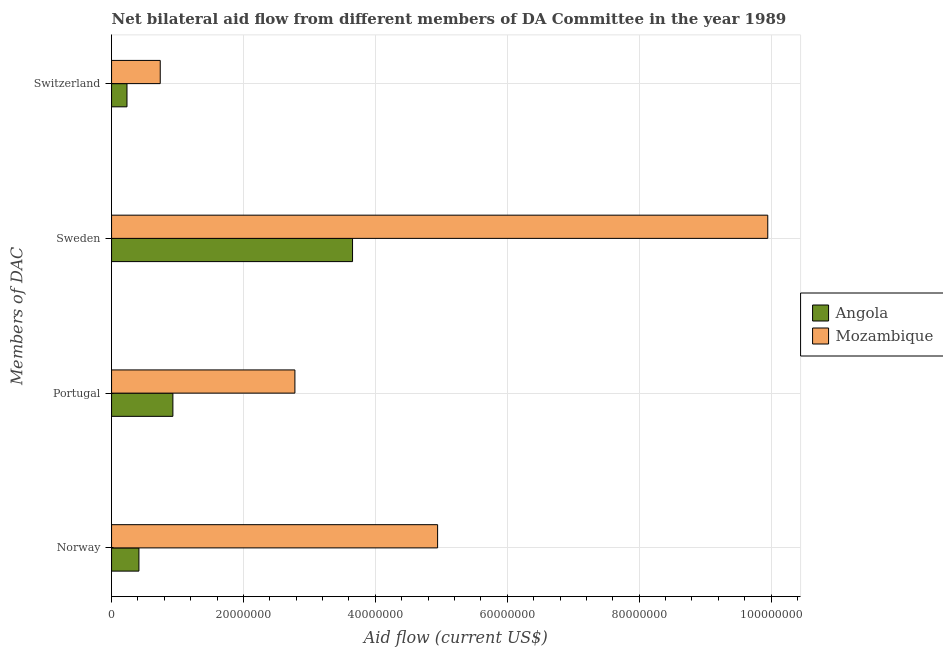How many different coloured bars are there?
Your answer should be compact. 2. How many groups of bars are there?
Make the answer very short. 4. Are the number of bars on each tick of the Y-axis equal?
Provide a succinct answer. Yes. How many bars are there on the 4th tick from the bottom?
Ensure brevity in your answer.  2. What is the label of the 2nd group of bars from the top?
Your answer should be very brief. Sweden. What is the amount of aid given by sweden in Mozambique?
Your answer should be compact. 9.95e+07. Across all countries, what is the maximum amount of aid given by norway?
Your answer should be compact. 4.94e+07. Across all countries, what is the minimum amount of aid given by norway?
Offer a terse response. 4.15e+06. In which country was the amount of aid given by switzerland maximum?
Your answer should be very brief. Mozambique. In which country was the amount of aid given by switzerland minimum?
Provide a succinct answer. Angola. What is the total amount of aid given by sweden in the graph?
Keep it short and to the point. 1.36e+08. What is the difference between the amount of aid given by portugal in Angola and that in Mozambique?
Keep it short and to the point. -1.85e+07. What is the difference between the amount of aid given by norway in Mozambique and the amount of aid given by switzerland in Angola?
Your response must be concise. 4.71e+07. What is the average amount of aid given by switzerland per country?
Ensure brevity in your answer.  4.86e+06. What is the difference between the amount of aid given by norway and amount of aid given by sweden in Mozambique?
Provide a succinct answer. -5.01e+07. In how many countries, is the amount of aid given by portugal greater than 28000000 US$?
Offer a terse response. 0. What is the ratio of the amount of aid given by norway in Mozambique to that in Angola?
Keep it short and to the point. 11.91. Is the amount of aid given by sweden in Mozambique less than that in Angola?
Your response must be concise. No. What is the difference between the highest and the second highest amount of aid given by norway?
Give a very brief answer. 4.53e+07. What is the difference between the highest and the lowest amount of aid given by portugal?
Make the answer very short. 1.85e+07. Is the sum of the amount of aid given by switzerland in Mozambique and Angola greater than the maximum amount of aid given by sweden across all countries?
Offer a very short reply. No. What does the 2nd bar from the top in Sweden represents?
Your answer should be very brief. Angola. What does the 2nd bar from the bottom in Norway represents?
Make the answer very short. Mozambique. Is it the case that in every country, the sum of the amount of aid given by norway and amount of aid given by portugal is greater than the amount of aid given by sweden?
Your answer should be compact. No. How many bars are there?
Make the answer very short. 8. How many countries are there in the graph?
Offer a terse response. 2. Are the values on the major ticks of X-axis written in scientific E-notation?
Give a very brief answer. No. Does the graph contain any zero values?
Your answer should be very brief. No. Does the graph contain grids?
Provide a succinct answer. Yes. Where does the legend appear in the graph?
Give a very brief answer. Center right. How are the legend labels stacked?
Ensure brevity in your answer.  Vertical. What is the title of the graph?
Provide a succinct answer. Net bilateral aid flow from different members of DA Committee in the year 1989. What is the label or title of the Y-axis?
Offer a terse response. Members of DAC. What is the Aid flow (current US$) of Angola in Norway?
Your response must be concise. 4.15e+06. What is the Aid flow (current US$) of Mozambique in Norway?
Provide a succinct answer. 4.94e+07. What is the Aid flow (current US$) of Angola in Portugal?
Make the answer very short. 9.30e+06. What is the Aid flow (current US$) of Mozambique in Portugal?
Offer a terse response. 2.78e+07. What is the Aid flow (current US$) of Angola in Sweden?
Your answer should be compact. 3.65e+07. What is the Aid flow (current US$) in Mozambique in Sweden?
Make the answer very short. 9.95e+07. What is the Aid flow (current US$) in Angola in Switzerland?
Your response must be concise. 2.34e+06. What is the Aid flow (current US$) of Mozambique in Switzerland?
Your answer should be very brief. 7.38e+06. Across all Members of DAC, what is the maximum Aid flow (current US$) of Angola?
Ensure brevity in your answer.  3.65e+07. Across all Members of DAC, what is the maximum Aid flow (current US$) in Mozambique?
Provide a succinct answer. 9.95e+07. Across all Members of DAC, what is the minimum Aid flow (current US$) of Angola?
Give a very brief answer. 2.34e+06. Across all Members of DAC, what is the minimum Aid flow (current US$) in Mozambique?
Provide a succinct answer. 7.38e+06. What is the total Aid flow (current US$) of Angola in the graph?
Offer a very short reply. 5.23e+07. What is the total Aid flow (current US$) in Mozambique in the graph?
Your response must be concise. 1.84e+08. What is the difference between the Aid flow (current US$) of Angola in Norway and that in Portugal?
Ensure brevity in your answer.  -5.15e+06. What is the difference between the Aid flow (current US$) in Mozambique in Norway and that in Portugal?
Your answer should be compact. 2.16e+07. What is the difference between the Aid flow (current US$) of Angola in Norway and that in Sweden?
Your response must be concise. -3.24e+07. What is the difference between the Aid flow (current US$) in Mozambique in Norway and that in Sweden?
Give a very brief answer. -5.01e+07. What is the difference between the Aid flow (current US$) in Angola in Norway and that in Switzerland?
Give a very brief answer. 1.81e+06. What is the difference between the Aid flow (current US$) in Mozambique in Norway and that in Switzerland?
Provide a short and direct response. 4.21e+07. What is the difference between the Aid flow (current US$) of Angola in Portugal and that in Sweden?
Your response must be concise. -2.72e+07. What is the difference between the Aid flow (current US$) of Mozambique in Portugal and that in Sweden?
Provide a succinct answer. -7.17e+07. What is the difference between the Aid flow (current US$) of Angola in Portugal and that in Switzerland?
Your answer should be very brief. 6.96e+06. What is the difference between the Aid flow (current US$) of Mozambique in Portugal and that in Switzerland?
Make the answer very short. 2.04e+07. What is the difference between the Aid flow (current US$) of Angola in Sweden and that in Switzerland?
Ensure brevity in your answer.  3.42e+07. What is the difference between the Aid flow (current US$) of Mozambique in Sweden and that in Switzerland?
Keep it short and to the point. 9.21e+07. What is the difference between the Aid flow (current US$) in Angola in Norway and the Aid flow (current US$) in Mozambique in Portugal?
Give a very brief answer. -2.36e+07. What is the difference between the Aid flow (current US$) in Angola in Norway and the Aid flow (current US$) in Mozambique in Sweden?
Provide a short and direct response. -9.54e+07. What is the difference between the Aid flow (current US$) of Angola in Norway and the Aid flow (current US$) of Mozambique in Switzerland?
Your response must be concise. -3.23e+06. What is the difference between the Aid flow (current US$) of Angola in Portugal and the Aid flow (current US$) of Mozambique in Sweden?
Your answer should be very brief. -9.02e+07. What is the difference between the Aid flow (current US$) of Angola in Portugal and the Aid flow (current US$) of Mozambique in Switzerland?
Make the answer very short. 1.92e+06. What is the difference between the Aid flow (current US$) in Angola in Sweden and the Aid flow (current US$) in Mozambique in Switzerland?
Keep it short and to the point. 2.92e+07. What is the average Aid flow (current US$) in Angola per Members of DAC?
Your answer should be very brief. 1.31e+07. What is the average Aid flow (current US$) in Mozambique per Members of DAC?
Provide a succinct answer. 4.60e+07. What is the difference between the Aid flow (current US$) of Angola and Aid flow (current US$) of Mozambique in Norway?
Offer a very short reply. -4.53e+07. What is the difference between the Aid flow (current US$) in Angola and Aid flow (current US$) in Mozambique in Portugal?
Your answer should be very brief. -1.85e+07. What is the difference between the Aid flow (current US$) of Angola and Aid flow (current US$) of Mozambique in Sweden?
Provide a succinct answer. -6.30e+07. What is the difference between the Aid flow (current US$) in Angola and Aid flow (current US$) in Mozambique in Switzerland?
Give a very brief answer. -5.04e+06. What is the ratio of the Aid flow (current US$) in Angola in Norway to that in Portugal?
Your answer should be compact. 0.45. What is the ratio of the Aid flow (current US$) of Mozambique in Norway to that in Portugal?
Provide a succinct answer. 1.78. What is the ratio of the Aid flow (current US$) of Angola in Norway to that in Sweden?
Ensure brevity in your answer.  0.11. What is the ratio of the Aid flow (current US$) of Mozambique in Norway to that in Sweden?
Offer a very short reply. 0.5. What is the ratio of the Aid flow (current US$) of Angola in Norway to that in Switzerland?
Your response must be concise. 1.77. What is the ratio of the Aid flow (current US$) of Mozambique in Norway to that in Switzerland?
Your answer should be very brief. 6.7. What is the ratio of the Aid flow (current US$) in Angola in Portugal to that in Sweden?
Your answer should be compact. 0.25. What is the ratio of the Aid flow (current US$) in Mozambique in Portugal to that in Sweden?
Offer a terse response. 0.28. What is the ratio of the Aid flow (current US$) of Angola in Portugal to that in Switzerland?
Offer a very short reply. 3.97. What is the ratio of the Aid flow (current US$) of Mozambique in Portugal to that in Switzerland?
Provide a short and direct response. 3.77. What is the ratio of the Aid flow (current US$) of Angola in Sweden to that in Switzerland?
Give a very brief answer. 15.62. What is the ratio of the Aid flow (current US$) in Mozambique in Sweden to that in Switzerland?
Your answer should be very brief. 13.48. What is the difference between the highest and the second highest Aid flow (current US$) of Angola?
Provide a short and direct response. 2.72e+07. What is the difference between the highest and the second highest Aid flow (current US$) of Mozambique?
Provide a short and direct response. 5.01e+07. What is the difference between the highest and the lowest Aid flow (current US$) of Angola?
Make the answer very short. 3.42e+07. What is the difference between the highest and the lowest Aid flow (current US$) of Mozambique?
Make the answer very short. 9.21e+07. 